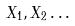Convert formula to latex. <formula><loc_0><loc_0><loc_500><loc_500>X _ { 1 } , X _ { 2 } \dots</formula> 